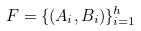Convert formula to latex. <formula><loc_0><loc_0><loc_500><loc_500>F = \{ ( A _ { i } , B _ { i } ) \} _ { i = 1 } ^ { h }</formula> 